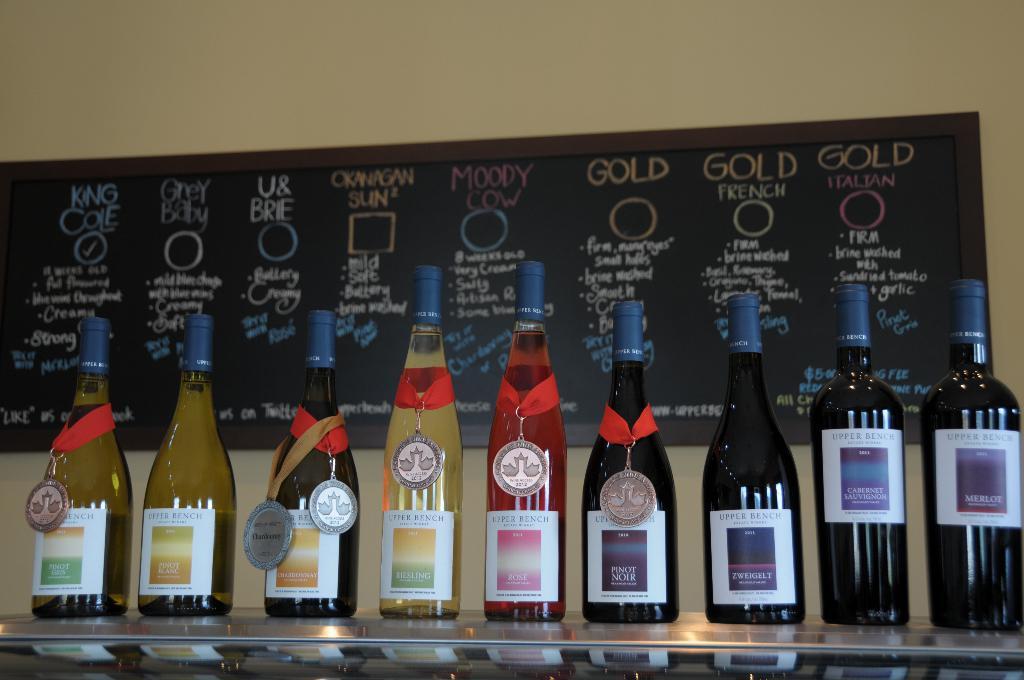What type of wine is on the bottle furthest right?
Provide a succinct answer. Merlot. 